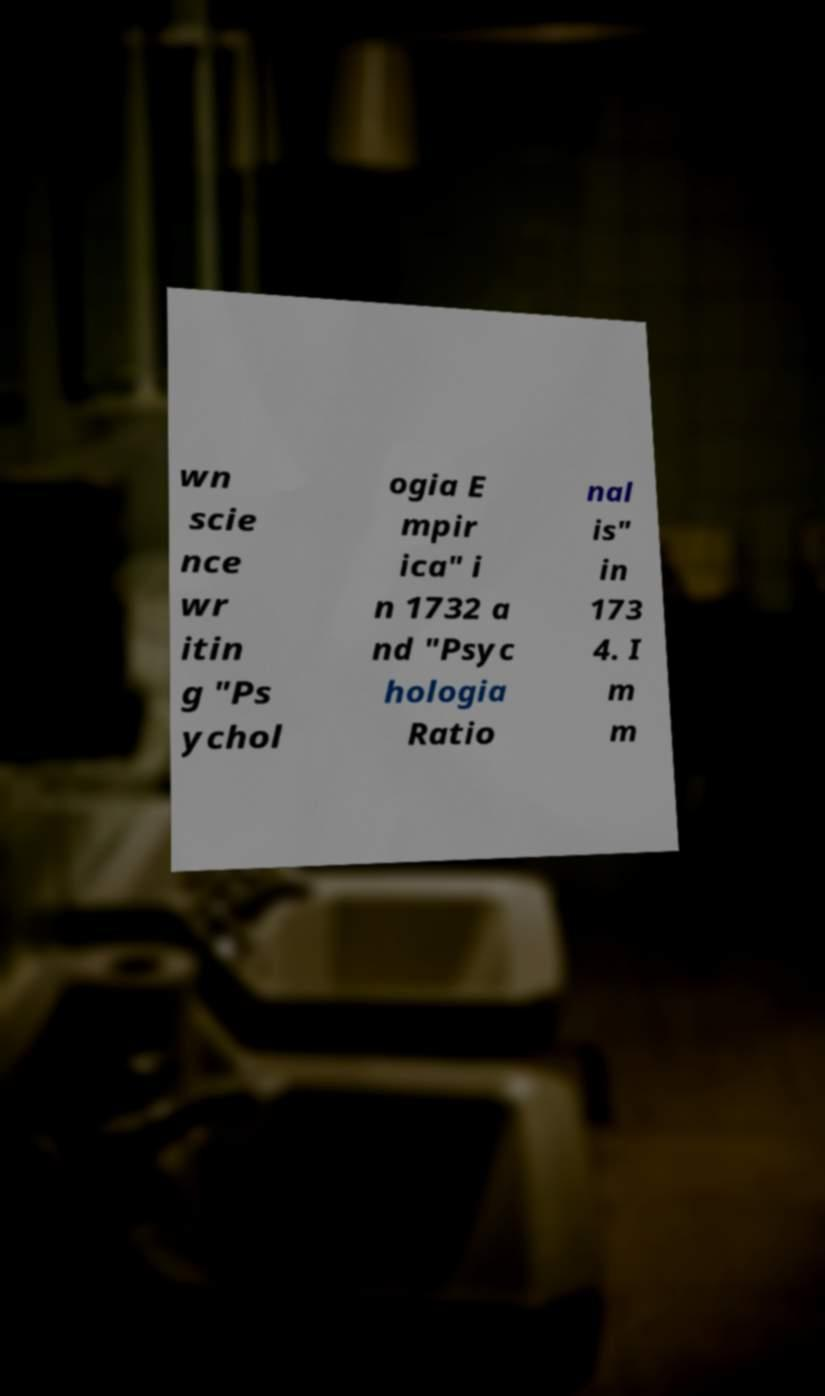Could you extract and type out the text from this image? wn scie nce wr itin g "Ps ychol ogia E mpir ica" i n 1732 a nd "Psyc hologia Ratio nal is" in 173 4. I m m 